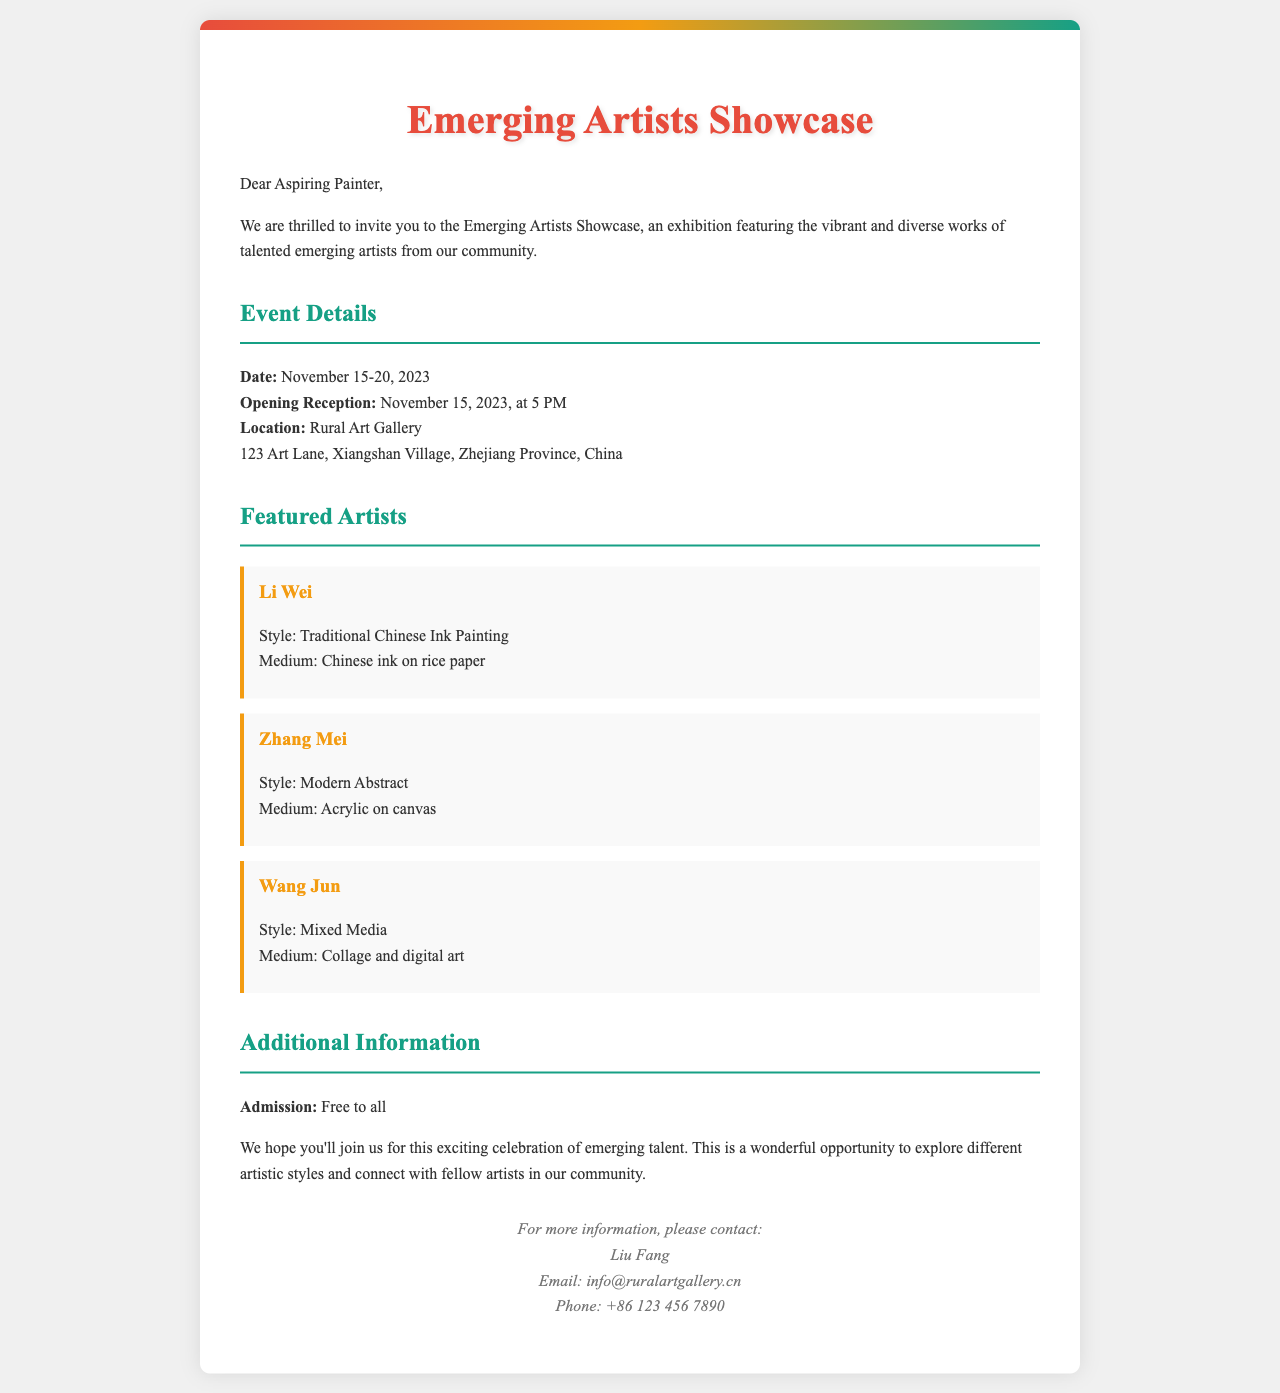What is the title of the event? The title of the event is prominently displayed in the letter as the main heading.
Answer: Emerging Artists Showcase When does the exhibition take place? The exhibition dates are specifically mentioned in the event details section of the document.
Answer: November 15-20, 2023 Where is the event being held? The location details are clearly stated in the event section.
Answer: Rural Art Gallery, 123 Art Lane, Xiangshan Village, Zhejiang Province, China Who is one of the featured artists? The names of the featured artists are listed in the document, highlighting their contributions to the exhibition.
Answer: Li Wei What style does Zhang Mei represent? The artistic style of Zhang Mei is described in the artist section of the document.
Answer: Modern Abstract How much does it cost to attend the exhibition? The admission details are provided in the additional information segment of the letter.
Answer: Free What type of artwork does Wang Jun create? Wang Jun's artistic style and medium are specified in his section, reflecting his artistic approach.
Answer: Mixed Media What time is the opening reception? The time of the opening reception is included in the event details section.
Answer: 5 PM Who should be contacted for more information? The contact for additional information is mentioned at the end of the document, indicating who to reach out to.
Answer: Liu Fang 